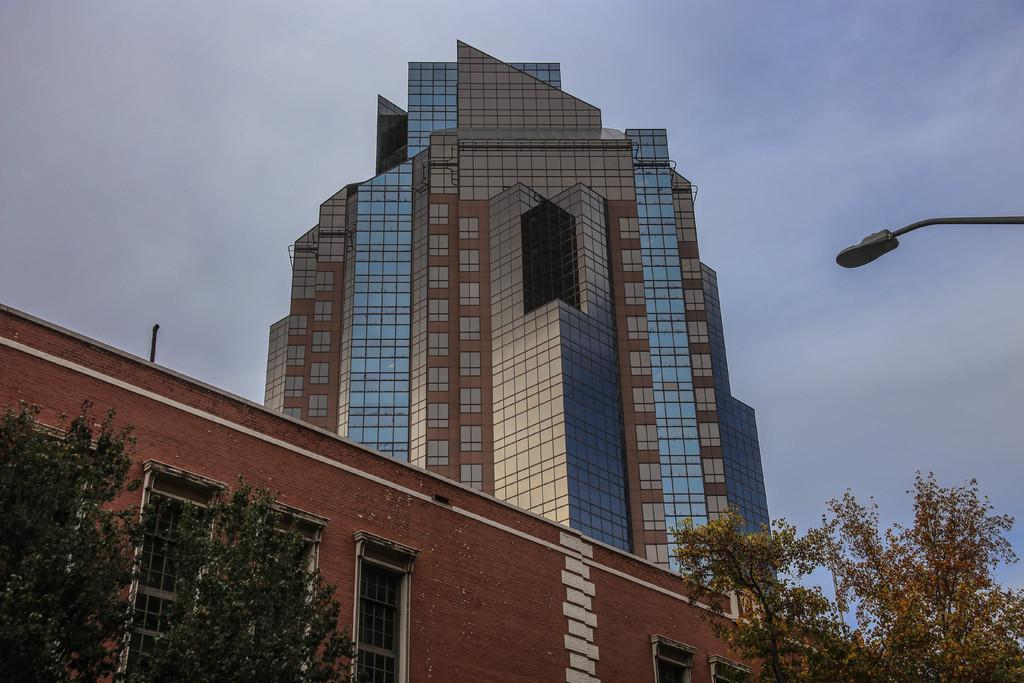What type of structures can be seen in the image? There are buildings in the image. What other natural elements are present in the image? There are trees in the image. Where is the light pole located in the image? The light pole is on the right side of the image. What is visible in the background of the image? The sky is visible in the image. What type of trousers is the tree wearing in the image? Trees do not wear trousers, as they are not human or capable of wearing clothing. 